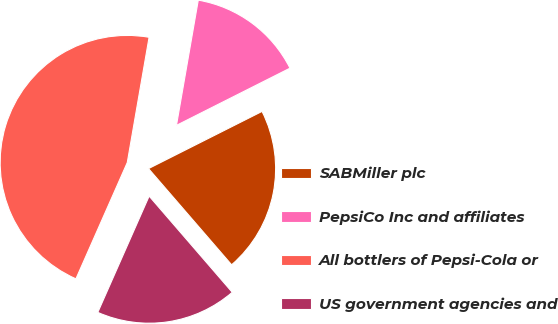Convert chart. <chart><loc_0><loc_0><loc_500><loc_500><pie_chart><fcel>SABMiller plc<fcel>PepsiCo Inc and affiliates<fcel>All bottlers of Pepsi-Cola or<fcel>US government agencies and<nl><fcel>21.09%<fcel>14.83%<fcel>46.13%<fcel>17.96%<nl></chart> 